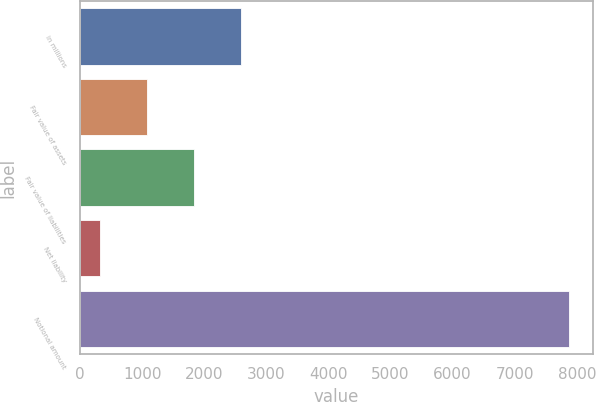Convert chart. <chart><loc_0><loc_0><loc_500><loc_500><bar_chart><fcel>in millions<fcel>Fair value of assets<fcel>Fair value of liabilities<fcel>Net liability<fcel>Notional amount<nl><fcel>2590.3<fcel>1082.1<fcel>1836.2<fcel>328<fcel>7869<nl></chart> 